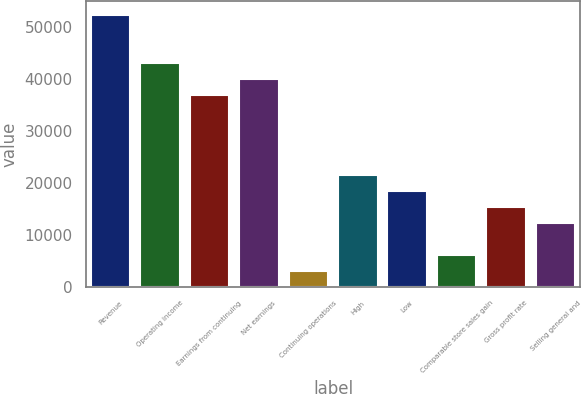Convert chart to OTSL. <chart><loc_0><loc_0><loc_500><loc_500><bar_chart><fcel>Revenue<fcel>Operating income<fcel>Earnings from continuing<fcel>Net earnings<fcel>Continuing operations<fcel>High<fcel>Low<fcel>Comparable store sales gain<fcel>Gross profit rate<fcel>Selling general and<nl><fcel>52440.7<fcel>43186.7<fcel>37017.3<fcel>40102<fcel>3085.97<fcel>21594<fcel>18509.3<fcel>6170.64<fcel>15424.6<fcel>12340<nl></chart> 